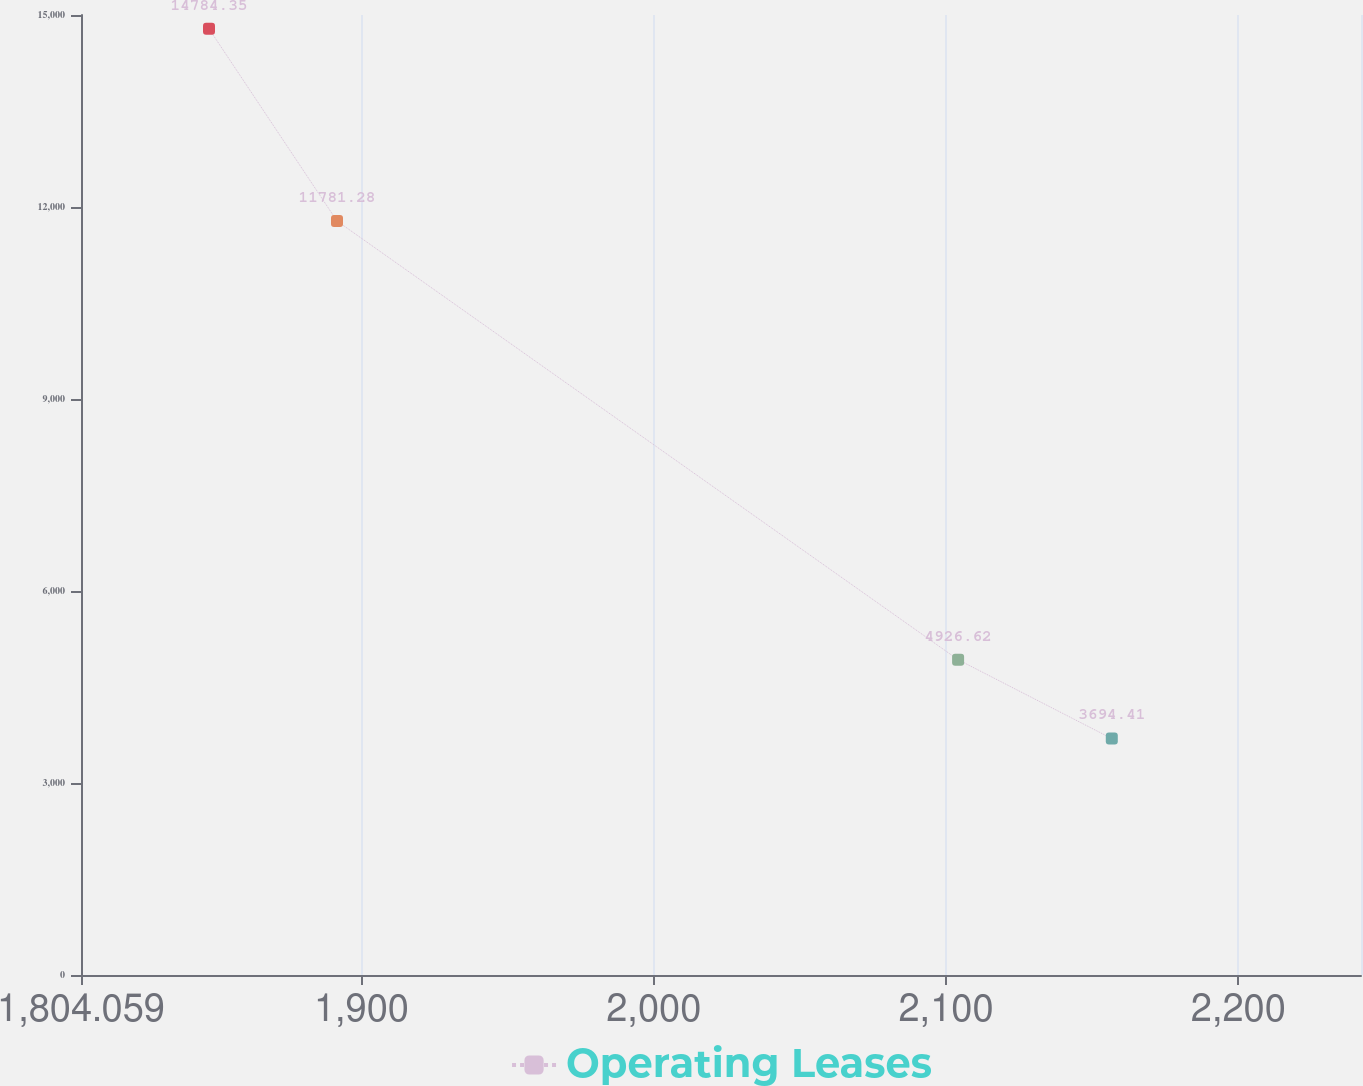Convert chart to OTSL. <chart><loc_0><loc_0><loc_500><loc_500><line_chart><ecel><fcel>Operating Leases<nl><fcel>1847.85<fcel>14784.4<nl><fcel>1891.64<fcel>11781.3<nl><fcel>2104.13<fcel>4926.62<nl><fcel>2156.71<fcel>3694.41<nl><fcel>2285.76<fcel>2462.2<nl></chart> 